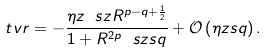Convert formula to latex. <formula><loc_0><loc_0><loc_500><loc_500>\ t v r = - \frac { \eta z \ s z R ^ { p - q + \frac { 1 } { 2 } } } { 1 + R ^ { 2 p } \ s z s q } + \mathcal { O } \left ( \eta z s q \right ) .</formula> 